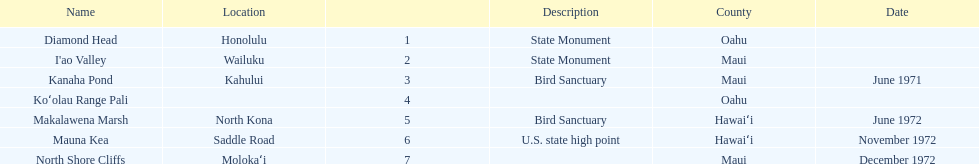What are the total number of landmarks located in maui? 3. Can you parse all the data within this table? {'header': ['Name', 'Location', '', 'Description', 'County', 'Date'], 'rows': [['Diamond Head', 'Honolulu', '1', 'State Monument', 'Oahu', ''], ["I'ao Valley", 'Wailuku', '2', 'State Monument', 'Maui', ''], ['Kanaha Pond', 'Kahului', '3', 'Bird Sanctuary', 'Maui', 'June 1971'], ['Koʻolau Range Pali', '', '4', '', 'Oahu', ''], ['Makalawena Marsh', 'North Kona', '5', 'Bird Sanctuary', 'Hawaiʻi', 'June 1972'], ['Mauna Kea', 'Saddle Road', '6', 'U.S. state high point', 'Hawaiʻi', 'November 1972'], ['North Shore Cliffs', 'Molokaʻi', '7', '', 'Maui', 'December 1972']]} 